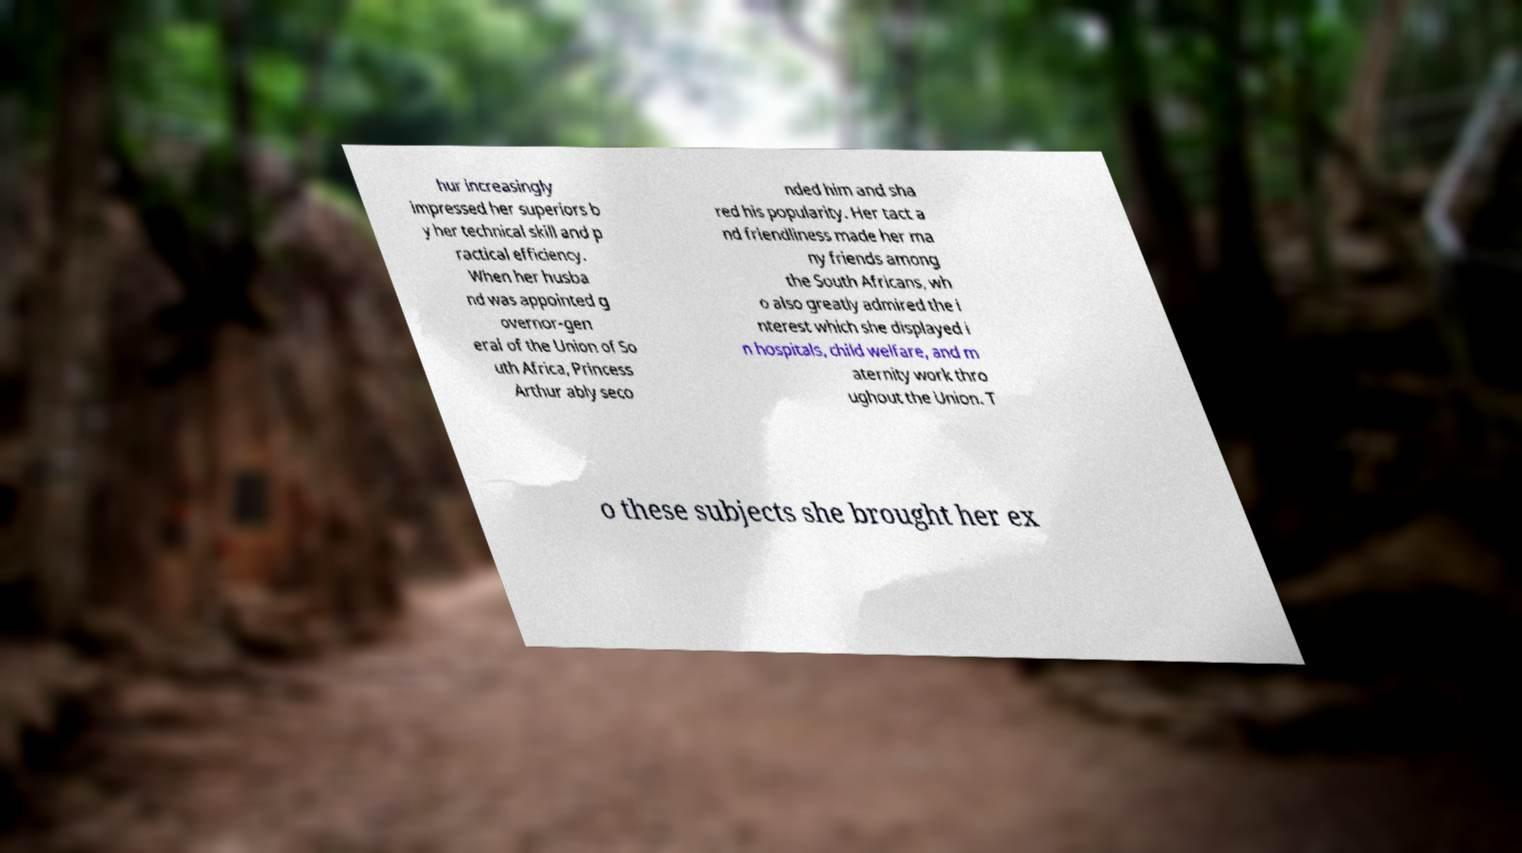Please identify and transcribe the text found in this image. hur increasingly impressed her superiors b y her technical skill and p ractical efficiency. When her husba nd was appointed g overnor-gen eral of the Union of So uth Africa, Princess Arthur ably seco nded him and sha red his popularity. Her tact a nd friendliness made her ma ny friends among the South Africans, wh o also greatly admired the i nterest which she displayed i n hospitals, child welfare, and m aternity work thro ughout the Union. T o these subjects she brought her ex 